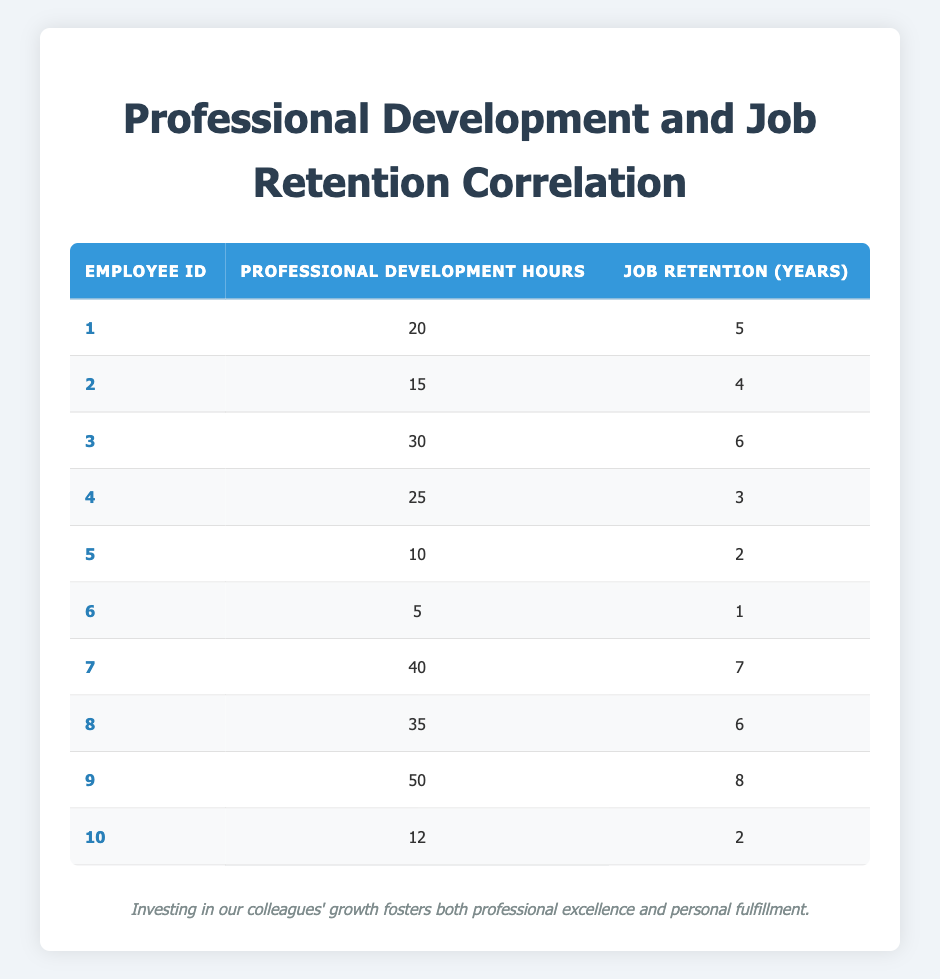What is the highest number of professional development hours recorded in the table? The table displays the professional development hours for each employee. By scanning the "Professional Development Hours" column, Employee ID 9 has 50 hours, which is the maximum value listed.
Answer: 50 What is the job retention years of Employee ID 4? Looking at the table, I find Employee ID 4 listed under "Job Retention (Years)" and the value corresponding to that ID is 3 years.
Answer: 3 How many employees have more than 30 professional development hours? By checking the "Professional Development Hours" column, I can see which employees exceed the 30-hour mark. Employee IDs 3, 7, 8, and 9 have more than 30 hours, totaling 4 employees.
Answer: 4 What is the average job retention for all employees? To calculate the average job retention, I sum the "Job Retention (Years)" values: 5 + 4 + 6 + 3 + 2 + 1 + 7 + 6 + 8 + 2 = 44 years. Then I divide this total by the number of employees (10): 44 / 10 = 4.4 years.
Answer: 4.4 Is there a correlation between increased professional development hours and longer job retention years in the table? The data suggests a trend; for example, employees with higher professional development hours generally have longer job retention years. However, to assert a direct correlation, statistical analysis would be needed. For this visual inspection, it appears that higher hours correlate with longer retention.
Answer: Yes How many employees have more than 4 job retention years? Reviewing the "Job Retention (Years)" column, Employees 1, 3, 7, 8, and 9 have job retention years greater than 4, totaling 5 employees.
Answer: 5 What is the difference between the maximum and minimum job retention years in the table? The maximum job retention year is 8 (Employee ID 9) and the minimum is 1 (Employee ID 6). The difference is calculated as 8 - 1 = 7 years.
Answer: 7 Which employee has the least professional development hours and what are their job retention years? Employee ID 6 has the least professional development hours at 5. Their corresponding job retention years are 1 year, based on the "Job Retention (Years)" column.
Answer: Employee ID 6, 1 year 